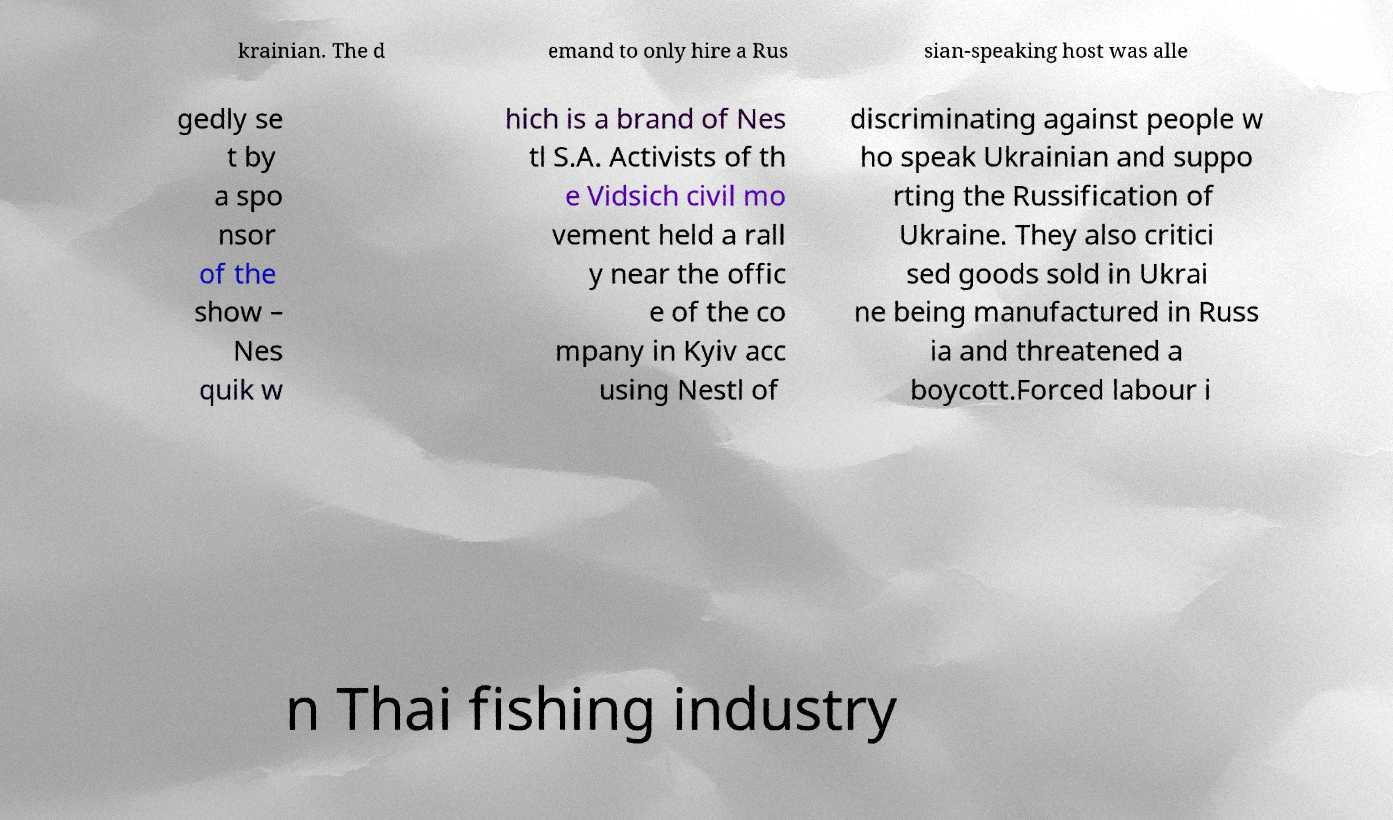Could you extract and type out the text from this image? krainian. The d emand to only hire a Rus sian-speaking host was alle gedly se t by a spo nsor of the show – Nes quik w hich is a brand of Nes tl S.A. Activists of th e Vidsich civil mo vement held a rall y near the offic e of the co mpany in Kyiv acc using Nestl of discriminating against people w ho speak Ukrainian and suppo rting the Russification of Ukraine. They also critici sed goods sold in Ukrai ne being manufactured in Russ ia and threatened a boycott.Forced labour i n Thai fishing industry 